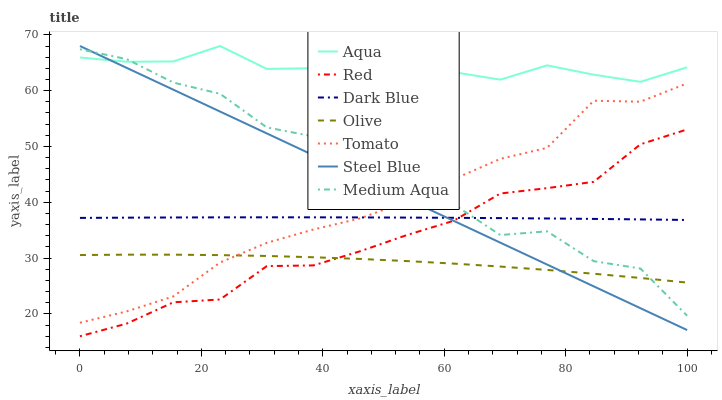Does Olive have the minimum area under the curve?
Answer yes or no. Yes. Does Aqua have the maximum area under the curve?
Answer yes or no. Yes. Does Steel Blue have the minimum area under the curve?
Answer yes or no. No. Does Steel Blue have the maximum area under the curve?
Answer yes or no. No. Is Steel Blue the smoothest?
Answer yes or no. Yes. Is Medium Aqua the roughest?
Answer yes or no. Yes. Is Aqua the smoothest?
Answer yes or no. No. Is Aqua the roughest?
Answer yes or no. No. Does Red have the lowest value?
Answer yes or no. Yes. Does Steel Blue have the lowest value?
Answer yes or no. No. Does Steel Blue have the highest value?
Answer yes or no. Yes. Does Dark Blue have the highest value?
Answer yes or no. No. Is Dark Blue less than Aqua?
Answer yes or no. Yes. Is Aqua greater than Red?
Answer yes or no. Yes. Does Red intersect Dark Blue?
Answer yes or no. Yes. Is Red less than Dark Blue?
Answer yes or no. No. Is Red greater than Dark Blue?
Answer yes or no. No. Does Dark Blue intersect Aqua?
Answer yes or no. No. 